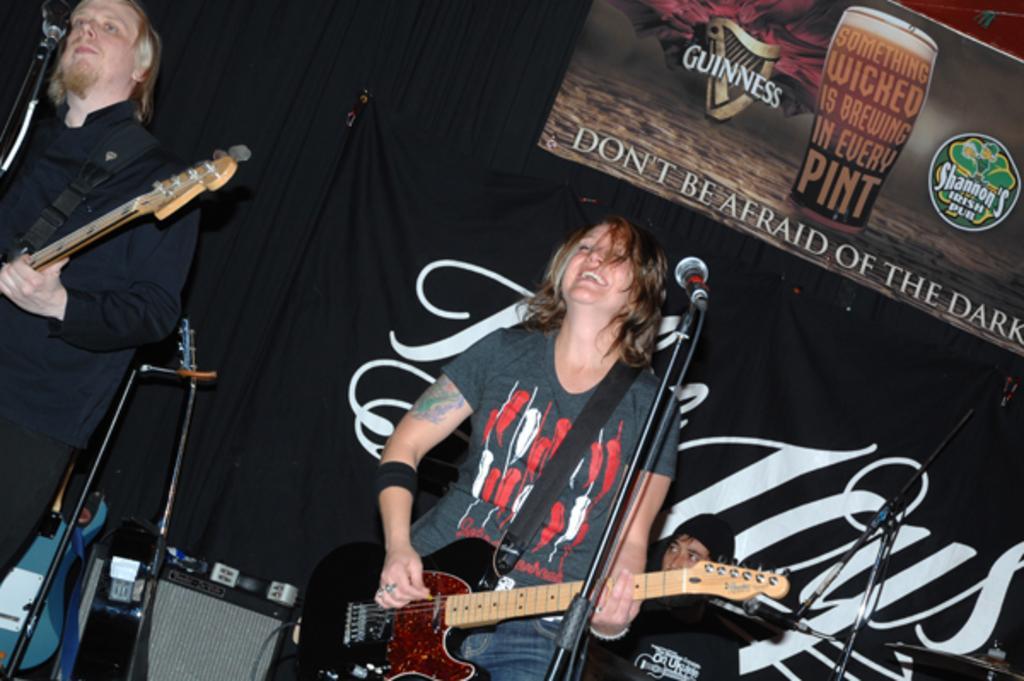Can you describe this image briefly? In the image there is a man and woman playing guitar in front of mic and behind them there are speakers and another person playing drum and there is a banner with some text at the back. 